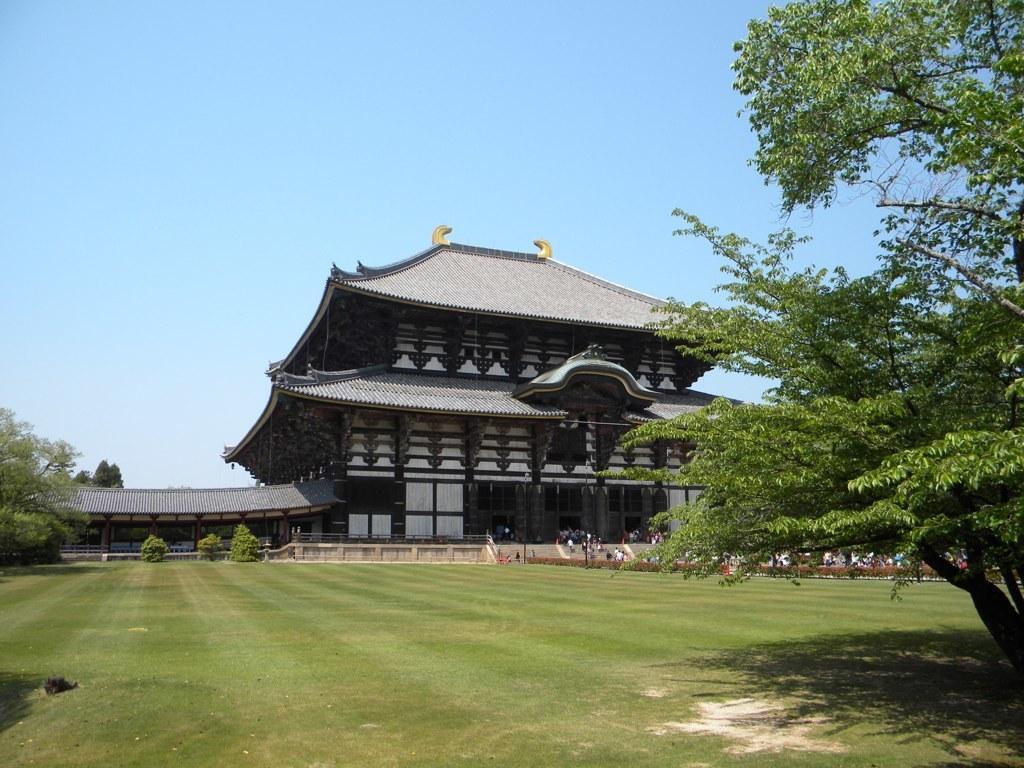How would you summarize this image in a sentence or two? Sky is in blue color. Here we can see a building. In-front of this building there are trees, people and grass. 